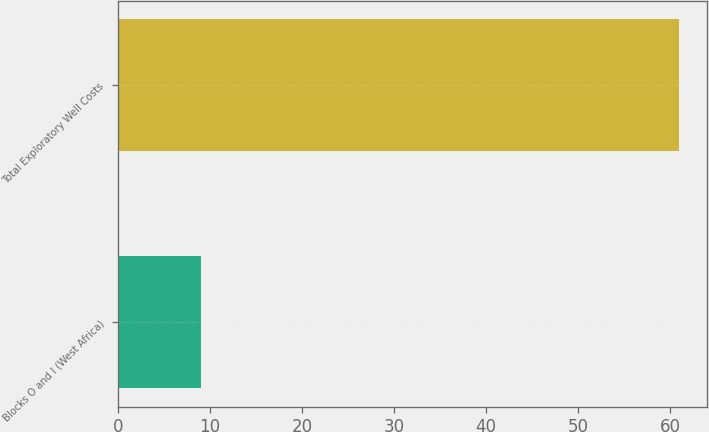Convert chart to OTSL. <chart><loc_0><loc_0><loc_500><loc_500><bar_chart><fcel>Blocks O and I (West Africa)<fcel>Total Exploratory Well Costs<nl><fcel>9<fcel>61<nl></chart> 